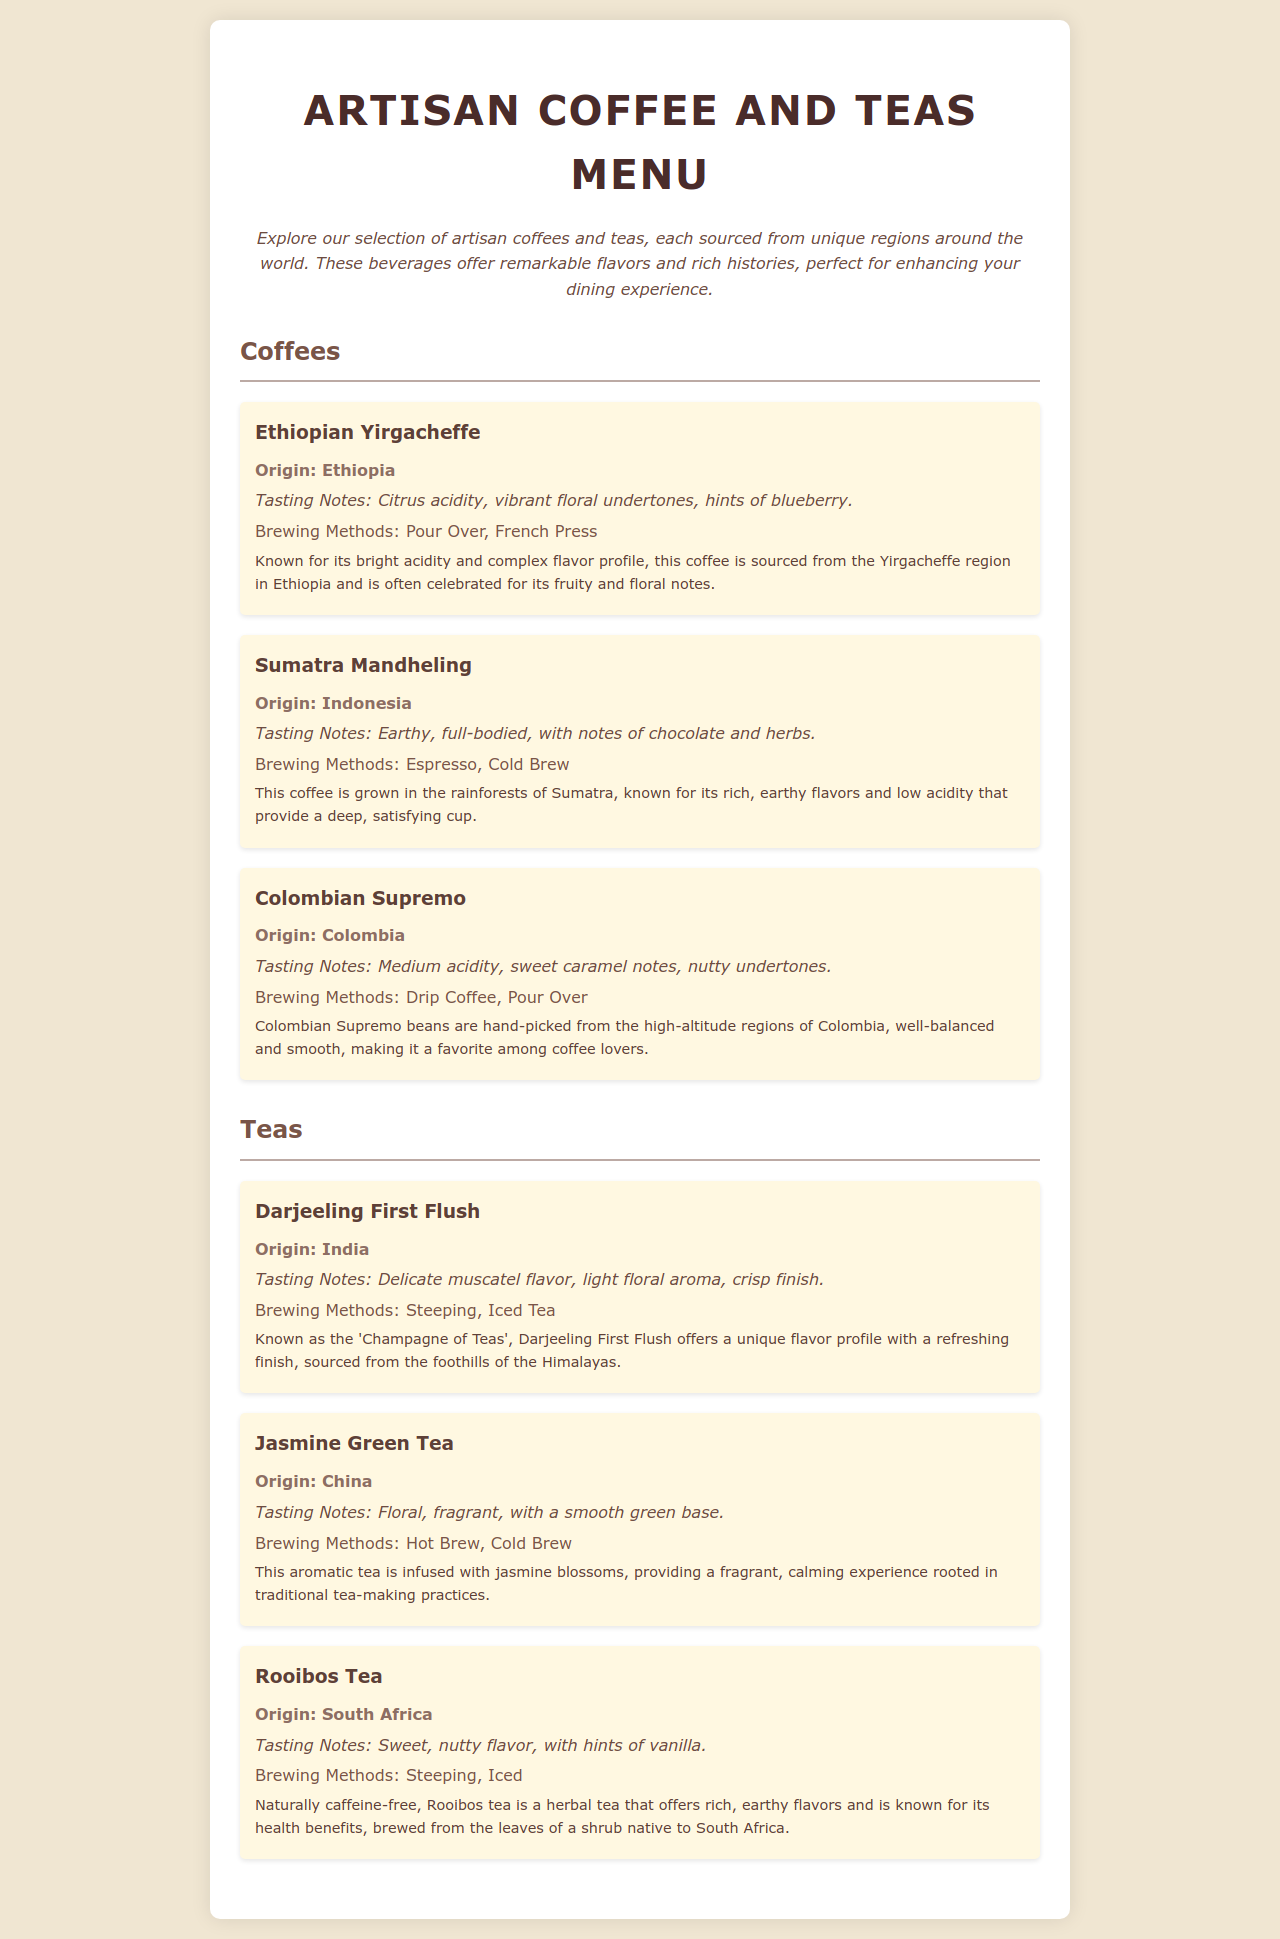What is the origin of Ethiopian Yirgacheffe? The document states that the origin of Ethiopian Yirgacheffe is Ethiopia.
Answer: Ethiopia What are the tasting notes of Sumatra Mandheling? The tasting notes provided in the document for Sumatra Mandheling are earthy, full-bodied, with notes of chocolate and herbs.
Answer: Earthy, full-bodied, with notes of chocolate and herbs Which brewing methods are suggested for Colombian Supremo? The brewing methods listed for Colombian Supremo in the document are Drip Coffee and Pour Over.
Answer: Drip Coffee, Pour Over What is the distinctive flavor profile of Darjeeling First Flush? The document mentions that Darjeeling First Flush has a delicate muscatel flavor with a light floral aroma and crisp finish.
Answer: Delicate muscatel flavor, light floral aroma, crisp finish Which tea is known as the 'Champagne of Teas'? The document describes Darjeeling First Flush as the 'Champagne of Teas'.
Answer: Darjeeling First Flush How many coffee items are listed in the menu? The document lists three coffee items under the Coffees section.
Answer: Three What is the brewing method for Rooibos Tea? According to the document, Rooibos Tea can be brewed by steeping or iced.
Answer: Steeping, Iced What region is Jasmine Green Tea sourced from? The document states that Jasmine Green Tea is sourced from China.
Answer: China What flavor notes are associated with Rooibos Tea? The flavor notes for Rooibos Tea mentioned in the document are sweet, nutty flavor, with hints of vanilla.
Answer: Sweet, nutty flavor, with hints of vanilla 